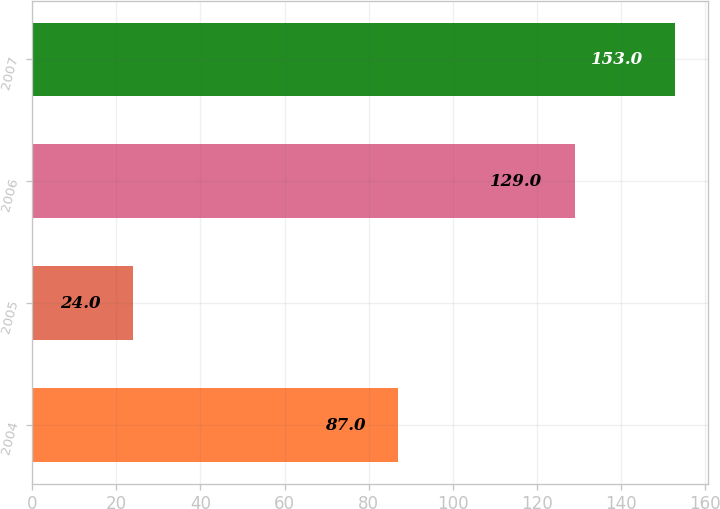Convert chart. <chart><loc_0><loc_0><loc_500><loc_500><bar_chart><fcel>2004<fcel>2005<fcel>2006<fcel>2007<nl><fcel>87<fcel>24<fcel>129<fcel>153<nl></chart> 